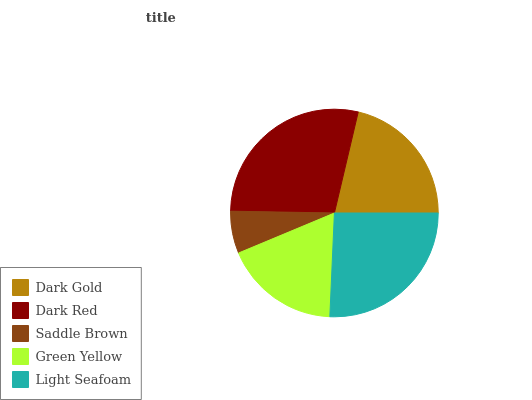Is Saddle Brown the minimum?
Answer yes or no. Yes. Is Dark Red the maximum?
Answer yes or no. Yes. Is Dark Red the minimum?
Answer yes or no. No. Is Saddle Brown the maximum?
Answer yes or no. No. Is Dark Red greater than Saddle Brown?
Answer yes or no. Yes. Is Saddle Brown less than Dark Red?
Answer yes or no. Yes. Is Saddle Brown greater than Dark Red?
Answer yes or no. No. Is Dark Red less than Saddle Brown?
Answer yes or no. No. Is Dark Gold the high median?
Answer yes or no. Yes. Is Dark Gold the low median?
Answer yes or no. Yes. Is Light Seafoam the high median?
Answer yes or no. No. Is Light Seafoam the low median?
Answer yes or no. No. 